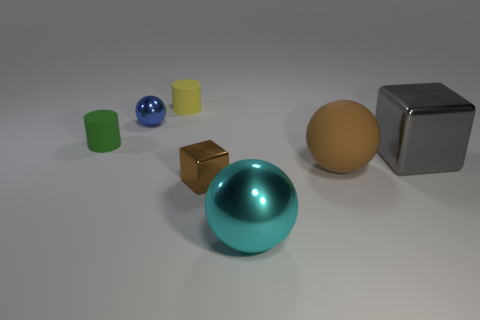Subtract 1 blocks. How many blocks are left? 1 Subtract all large spheres. How many spheres are left? 1 Subtract all spheres. How many objects are left? 4 Add 1 small rubber cylinders. How many small rubber cylinders exist? 3 Add 3 big brown rubber objects. How many objects exist? 10 Subtract all blue spheres. How many spheres are left? 2 Subtract 1 brown blocks. How many objects are left? 6 Subtract all yellow cylinders. Subtract all red blocks. How many cylinders are left? 1 Subtract all cyan cylinders. How many brown blocks are left? 1 Subtract all brown rubber objects. Subtract all large gray metal blocks. How many objects are left? 5 